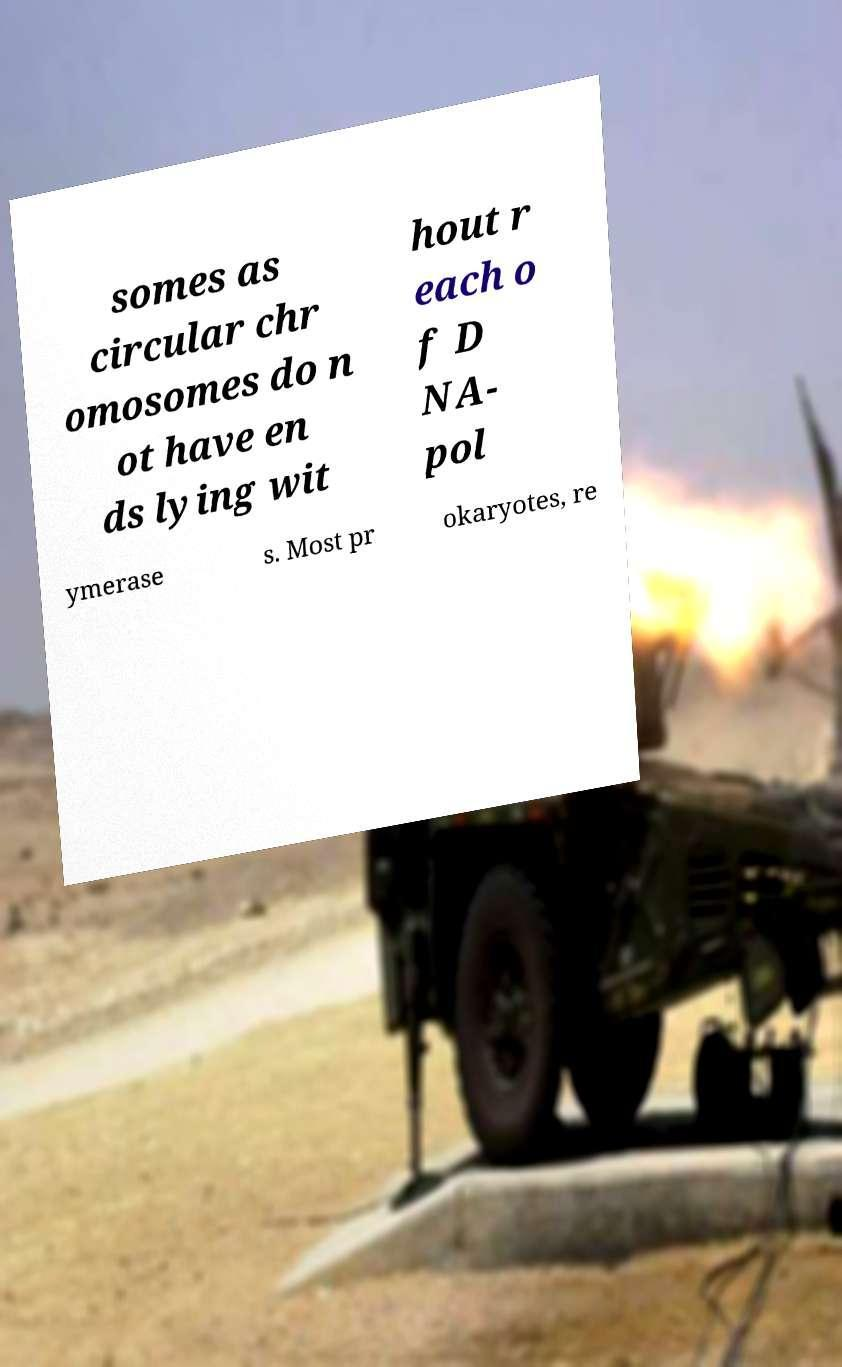Could you assist in decoding the text presented in this image and type it out clearly? somes as circular chr omosomes do n ot have en ds lying wit hout r each o f D NA- pol ymerase s. Most pr okaryotes, re 